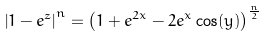Convert formula to latex. <formula><loc_0><loc_0><loc_500><loc_500>\left | 1 - e ^ { z } \right | ^ { n } = \left ( 1 + e ^ { 2 x } - 2 e ^ { x } \cos ( y ) \right ) ^ { \frac { n } { 2 } }</formula> 